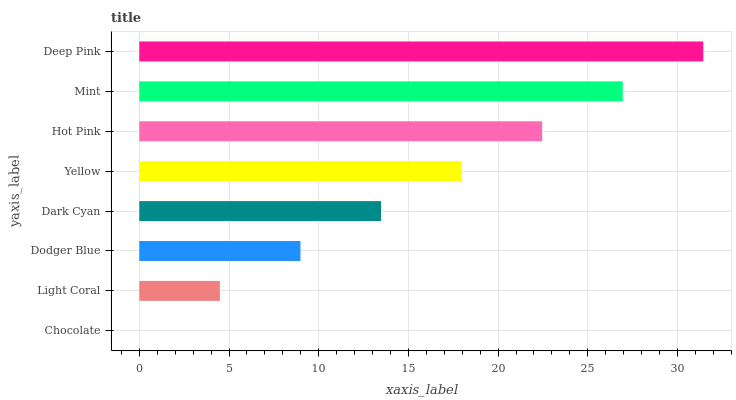Is Chocolate the minimum?
Answer yes or no. Yes. Is Deep Pink the maximum?
Answer yes or no. Yes. Is Light Coral the minimum?
Answer yes or no. No. Is Light Coral the maximum?
Answer yes or no. No. Is Light Coral greater than Chocolate?
Answer yes or no. Yes. Is Chocolate less than Light Coral?
Answer yes or no. Yes. Is Chocolate greater than Light Coral?
Answer yes or no. No. Is Light Coral less than Chocolate?
Answer yes or no. No. Is Yellow the high median?
Answer yes or no. Yes. Is Dark Cyan the low median?
Answer yes or no. Yes. Is Deep Pink the high median?
Answer yes or no. No. Is Dodger Blue the low median?
Answer yes or no. No. 